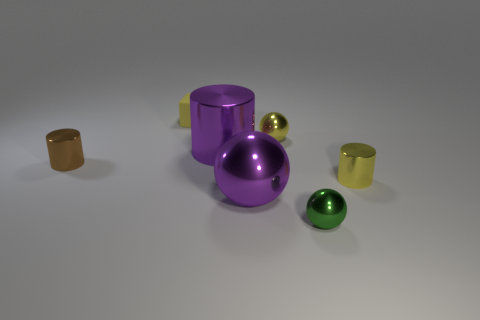Are there any other things that have the same material as the cube?
Your response must be concise. No. Do the small rubber thing and the brown thing have the same shape?
Your answer should be very brief. No. What number of shiny objects are either green balls or brown objects?
Provide a succinct answer. 2. There is a small cylinder that is the same color as the tiny matte cube; what is its material?
Your answer should be compact. Metal. Is the size of the brown cylinder the same as the green sphere?
Offer a terse response. Yes. How many objects are either yellow rubber objects or cylinders that are to the right of the brown cylinder?
Make the answer very short. 3. What is the material of the yellow cube that is the same size as the brown metallic cylinder?
Your answer should be compact. Rubber. What is the object that is to the left of the purple metallic cylinder and right of the brown metallic object made of?
Give a very brief answer. Rubber. Is there a big purple thing that is in front of the big purple thing that is behind the brown metal thing?
Make the answer very short. Yes. There is a shiny cylinder that is both on the right side of the brown cylinder and to the left of the yellow metal cylinder; how big is it?
Ensure brevity in your answer.  Large. 